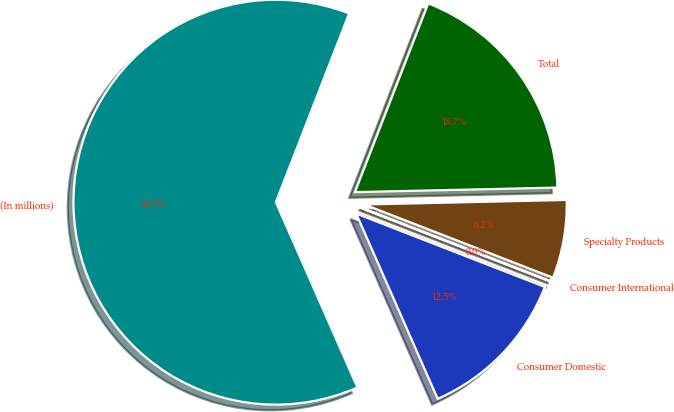Convert chart. <chart><loc_0><loc_0><loc_500><loc_500><pie_chart><fcel>(In millions)<fcel>Consumer Domestic<fcel>Consumer International<fcel>Specialty Products<fcel>Total<nl><fcel>62.49%<fcel>12.5%<fcel>0.01%<fcel>6.25%<fcel>18.75%<nl></chart> 